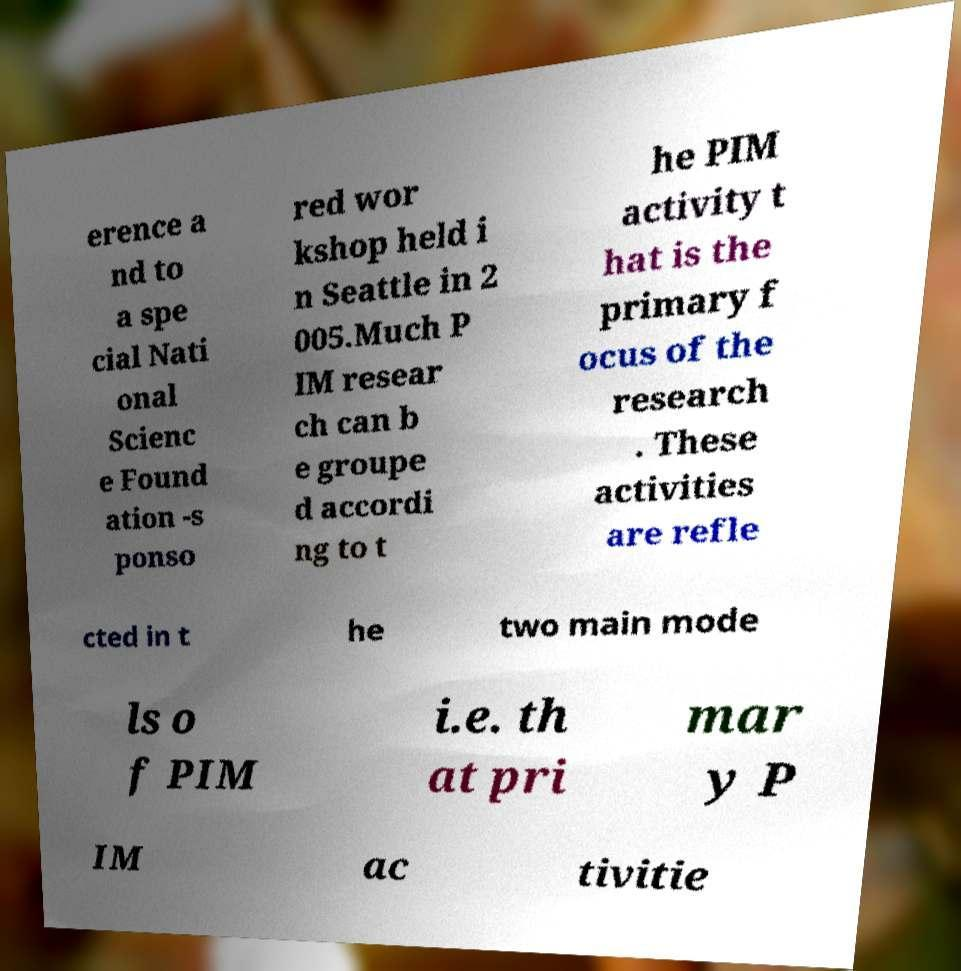I need the written content from this picture converted into text. Can you do that? erence a nd to a spe cial Nati onal Scienc e Found ation -s ponso red wor kshop held i n Seattle in 2 005.Much P IM resear ch can b e groupe d accordi ng to t he PIM activity t hat is the primary f ocus of the research . These activities are refle cted in t he two main mode ls o f PIM i.e. th at pri mar y P IM ac tivitie 